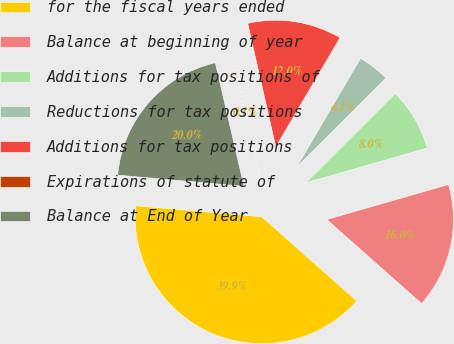Convert chart to OTSL. <chart><loc_0><loc_0><loc_500><loc_500><pie_chart><fcel>for the fiscal years ended<fcel>Balance at beginning of year<fcel>Additions for tax positions of<fcel>Reductions for tax positions<fcel>Additions for tax positions<fcel>Expirations of statute of<fcel>Balance at End of Year<nl><fcel>39.86%<fcel>15.99%<fcel>8.03%<fcel>4.06%<fcel>12.01%<fcel>0.08%<fcel>19.97%<nl></chart> 